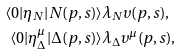Convert formula to latex. <formula><loc_0><loc_0><loc_500><loc_500>\langle 0 | \eta _ { N } | N ( p , s ) \rangle & \lambda _ { N } \upsilon ( p , s ) , \\ \langle 0 | \eta ^ { \mu } _ { \Delta } | \Delta ( p , s ) \rangle & \lambda _ { \Delta } \upsilon ^ { \mu } ( p , s ) ,</formula> 